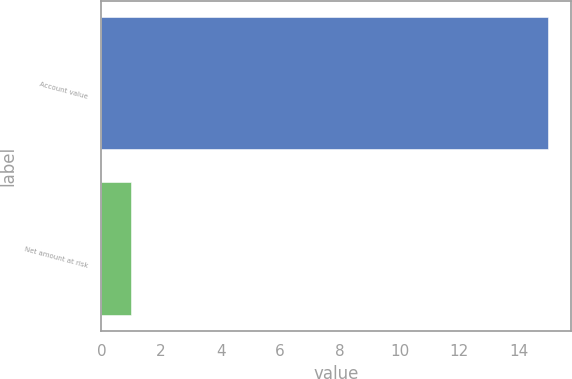Convert chart. <chart><loc_0><loc_0><loc_500><loc_500><bar_chart><fcel>Account value<fcel>Net amount at risk<nl><fcel>15<fcel>1<nl></chart> 